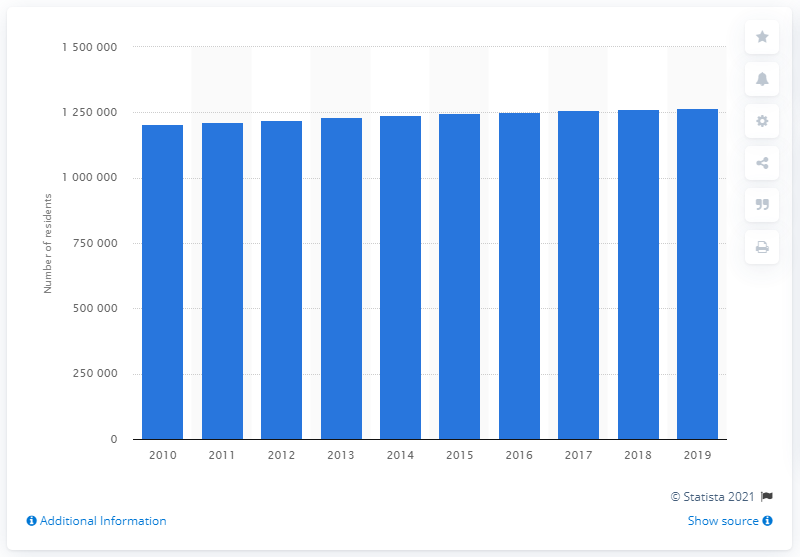Highlight a few significant elements in this photo. In 2019, the Louisville/Jefferson County metropolitan area had a population of 1,259,553 people. 